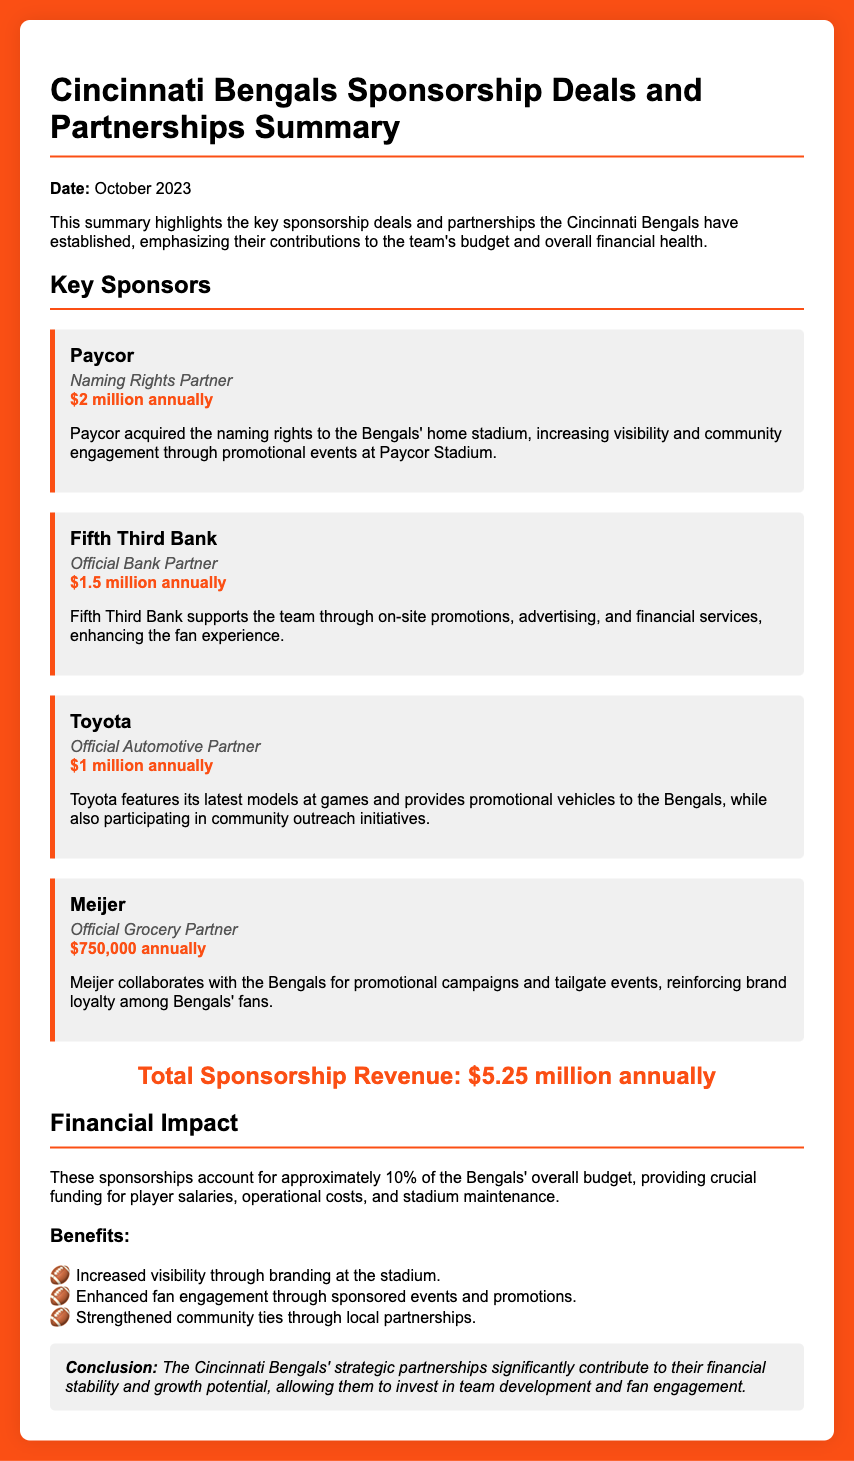What is the date of the report? The date mentioned in the report is provided at the beginning of the document.
Answer: October 2023 Who is the naming rights partner for the Bengals? The section on key sponsors highlights Paycor as the naming rights partner.
Answer: Paycor What is Fifth Third Bank's annual contribution? The annual contribution from Fifth Third Bank is specified in its sponsor card.
Answer: $1.5 million annually What percentage of the Bengals' overall budget do these sponsorships account for? The document states the percentage of the overall budget contributed by sponsorships.
Answer: 10% What are promotional events at Paycor Stadium associated with? The text describes promotional events in relation to the naming rights partnership with Paycor.
Answer: Visibility and community engagement What benefit is associated with community ties in the sponsorship section? The benefits section lists reasons why sponsorships are important, including community ties.
Answer: Strengthened community ties What is the total sponsorship revenue mentioned in the document? The total revenue figure is explicitly stated under the total revenue section.
Answer: $5.25 million annually What type of partnership is Toyota listed as? The sponsor card for Toyota describes its relationship with the team.
Answer: Official Automotive Partner 